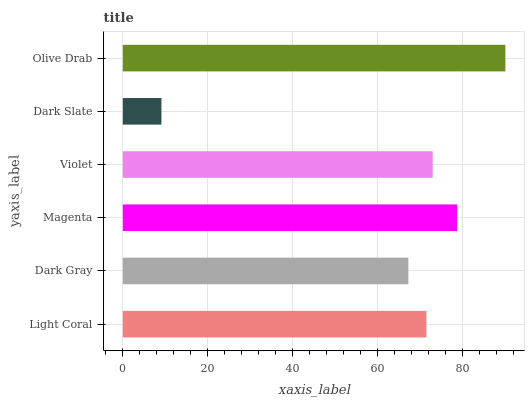Is Dark Slate the minimum?
Answer yes or no. Yes. Is Olive Drab the maximum?
Answer yes or no. Yes. Is Dark Gray the minimum?
Answer yes or no. No. Is Dark Gray the maximum?
Answer yes or no. No. Is Light Coral greater than Dark Gray?
Answer yes or no. Yes. Is Dark Gray less than Light Coral?
Answer yes or no. Yes. Is Dark Gray greater than Light Coral?
Answer yes or no. No. Is Light Coral less than Dark Gray?
Answer yes or no. No. Is Violet the high median?
Answer yes or no. Yes. Is Light Coral the low median?
Answer yes or no. Yes. Is Dark Slate the high median?
Answer yes or no. No. Is Violet the low median?
Answer yes or no. No. 